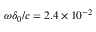Convert formula to latex. <formula><loc_0><loc_0><loc_500><loc_500>\omega \delta _ { 0 } / c = 2 . 4 \times 1 0 ^ { - 2 }</formula> 